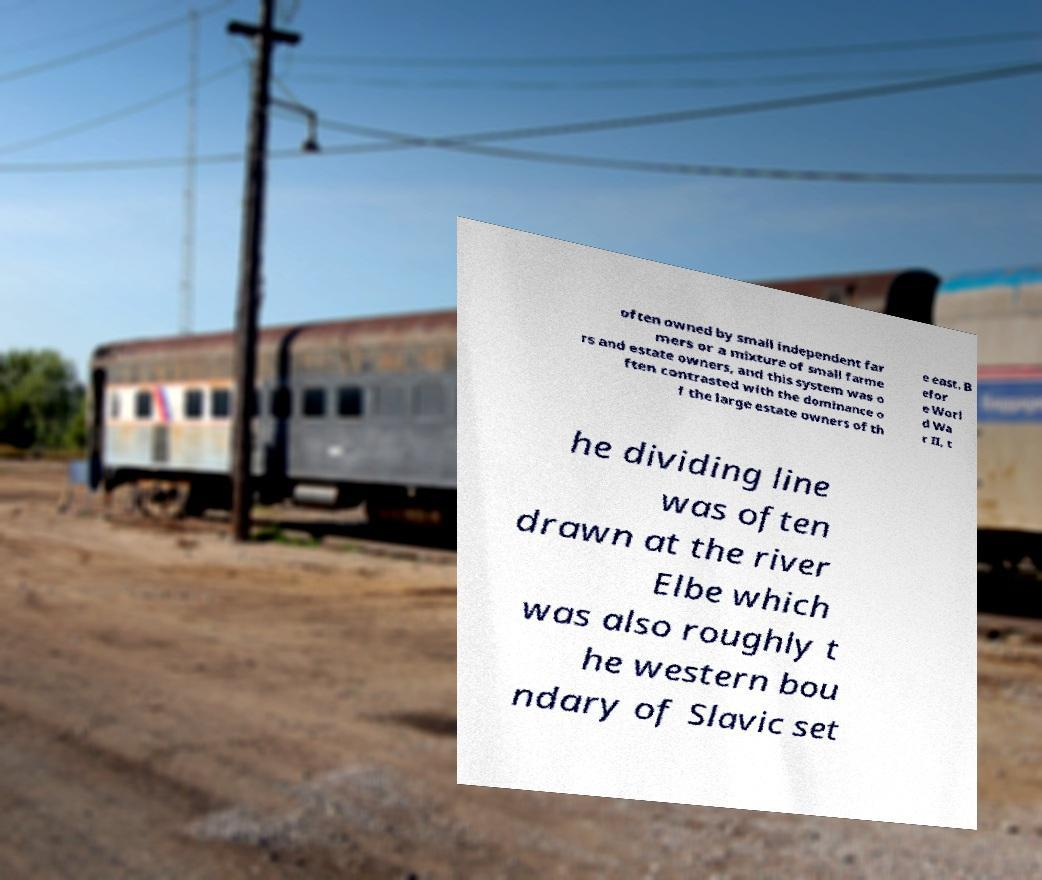Please read and relay the text visible in this image. What does it say? often owned by small independent far mers or a mixture of small farme rs and estate owners, and this system was o ften contrasted with the dominance o f the large estate owners of th e east. B efor e Worl d Wa r II, t he dividing line was often drawn at the river Elbe which was also roughly t he western bou ndary of Slavic set 